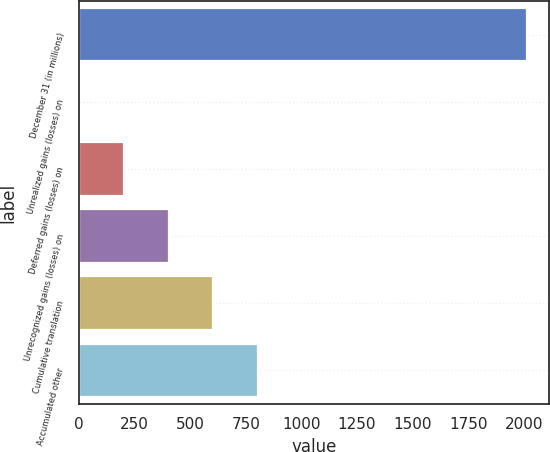Convert chart. <chart><loc_0><loc_0><loc_500><loc_500><bar_chart><fcel>December 31 (in millions)<fcel>Unrealized gains (losses) on<fcel>Deferred gains (losses) on<fcel>Unrecognized gains (losses) on<fcel>Cumulative translation<fcel>Accumulated other<nl><fcel>2014<fcel>1<fcel>202.3<fcel>403.6<fcel>604.9<fcel>806.2<nl></chart> 